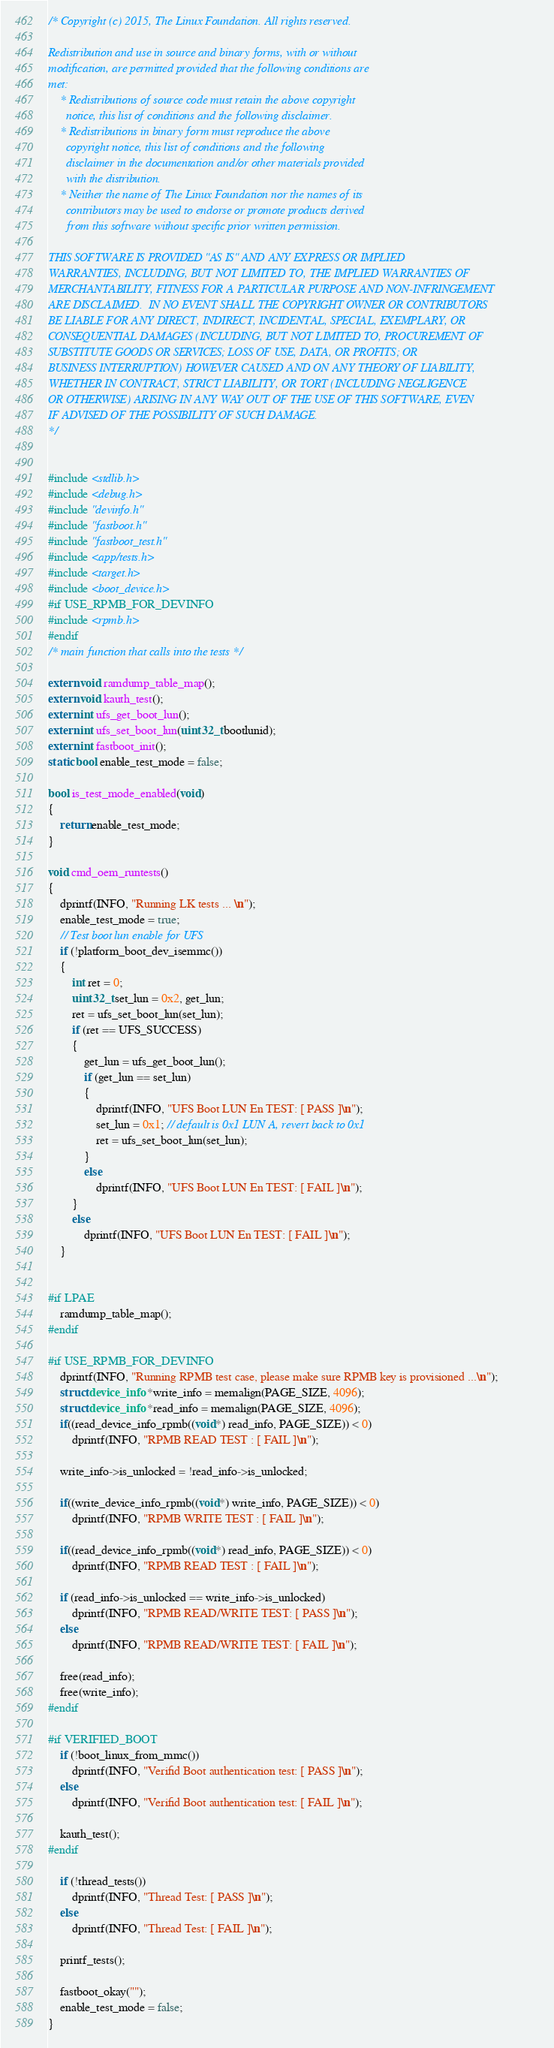<code> <loc_0><loc_0><loc_500><loc_500><_C_>/* Copyright (c) 2015, The Linux Foundation. All rights reserved.

Redistribution and use in source and binary forms, with or without
modification, are permitted provided that the following conditions are
met:
    * Redistributions of source code must retain the above copyright
      notice, this list of conditions and the following disclaimer.
    * Redistributions in binary form must reproduce the above
      copyright notice, this list of conditions and the following
      disclaimer in the documentation and/or other materials provided
      with the distribution.
    * Neither the name of The Linux Foundation nor the names of its
      contributors may be used to endorse or promote products derived
      from this software without specific prior written permission.

THIS SOFTWARE IS PROVIDED "AS IS" AND ANY EXPRESS OR IMPLIED
WARRANTIES, INCLUDING, BUT NOT LIMITED TO, THE IMPLIED WARRANTIES OF
MERCHANTABILITY, FITNESS FOR A PARTICULAR PURPOSE AND NON-INFRINGEMENT
ARE DISCLAIMED.  IN NO EVENT SHALL THE COPYRIGHT OWNER OR CONTRIBUTORS
BE LIABLE FOR ANY DIRECT, INDIRECT, INCIDENTAL, SPECIAL, EXEMPLARY, OR
CONSEQUENTIAL DAMAGES (INCLUDING, BUT NOT LIMITED TO, PROCUREMENT OF
SUBSTITUTE GOODS OR SERVICES; LOSS OF USE, DATA, OR PROFITS; OR
BUSINESS INTERRUPTION) HOWEVER CAUSED AND ON ANY THEORY OF LIABILITY,
WHETHER IN CONTRACT, STRICT LIABILITY, OR TORT (INCLUDING NEGLIGENCE
OR OTHERWISE) ARISING IN ANY WAY OUT OF THE USE OF THIS SOFTWARE, EVEN
IF ADVISED OF THE POSSIBILITY OF SUCH DAMAGE.
*/


#include <stdlib.h>
#include <debug.h>
#include "devinfo.h"
#include "fastboot.h"
#include "fastboot_test.h"
#include <app/tests.h>
#include <target.h>
#include <boot_device.h>
#if USE_RPMB_FOR_DEVINFO
#include <rpmb.h>
#endif
/* main function that calls into the tests */

extern void ramdump_table_map();
extern void kauth_test();
extern int ufs_get_boot_lun();
extern int ufs_set_boot_lun(uint32_t bootlunid);
extern int fastboot_init();
static bool enable_test_mode = false;

bool is_test_mode_enabled(void)
{
	return enable_test_mode;
}

void cmd_oem_runtests()
{
	dprintf(INFO, "Running LK tests ... \n");
	enable_test_mode = true;
	// Test boot lun enable for UFS
	if (!platform_boot_dev_isemmc())
	{
		int ret = 0;
		uint32_t set_lun = 0x2, get_lun;
		ret = ufs_set_boot_lun(set_lun);
		if (ret == UFS_SUCCESS)
		{
			get_lun = ufs_get_boot_lun();
			if (get_lun == set_lun)
			{
				dprintf(INFO, "UFS Boot LUN En TEST: [ PASS ]\n");
				set_lun = 0x1; // default is 0x1 LUN A, revert back to 0x1
				ret = ufs_set_boot_lun(set_lun);
			}
			else
				dprintf(INFO, "UFS Boot LUN En TEST: [ FAIL ]\n");
		}
		else
			dprintf(INFO, "UFS Boot LUN En TEST: [ FAIL ]\n");
	}


#if LPAE
	ramdump_table_map();
#endif

#if USE_RPMB_FOR_DEVINFO
	dprintf(INFO, "Running RPMB test case, please make sure RPMB key is provisioned ...\n");
	struct device_info *write_info = memalign(PAGE_SIZE, 4096);
	struct device_info *read_info = memalign(PAGE_SIZE, 4096);
	if((read_device_info_rpmb((void*) read_info, PAGE_SIZE)) < 0)
		dprintf(INFO, "RPMB READ TEST : [ FAIL ]\n");

	write_info->is_unlocked = !read_info->is_unlocked;

	if((write_device_info_rpmb((void*) write_info, PAGE_SIZE)) < 0)
		dprintf(INFO, "RPMB WRITE TEST : [ FAIL ]\n");

	if((read_device_info_rpmb((void*) read_info, PAGE_SIZE)) < 0)
		dprintf(INFO, "RPMB READ TEST : [ FAIL ]\n");

	if (read_info->is_unlocked == write_info->is_unlocked)
		dprintf(INFO, "RPMB READ/WRITE TEST: [ PASS ]\n");
	else
		dprintf(INFO, "RPMB READ/WRITE TEST: [ FAIL ]\n");

	free(read_info);
	free(write_info);
#endif

#if VERIFIED_BOOT
	if (!boot_linux_from_mmc())
		dprintf(INFO, "Verifid Boot authentication test: [ PASS ]\n");
	else
		dprintf(INFO, "Verifid Boot authentication test: [ FAIL ]\n");

	kauth_test();
#endif

	if (!thread_tests())
		dprintf(INFO, "Thread Test: [ PASS ]\n");
	else
		dprintf(INFO, "Thread Test: [ FAIL ]\n");

	printf_tests();

	fastboot_okay("");
	enable_test_mode = false;
}
</code> 